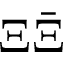<formula> <loc_0><loc_0><loc_500><loc_500>\Xi \bar { \Xi }</formula> 